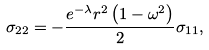<formula> <loc_0><loc_0><loc_500><loc_500>\sigma _ { 2 2 } = - \frac { e ^ { - \lambda } r ^ { 2 } \left ( 1 - \omega ^ { 2 } \right ) } { 2 } \sigma _ { 1 1 } ,</formula> 